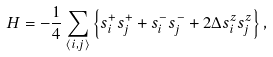Convert formula to latex. <formula><loc_0><loc_0><loc_500><loc_500>H = - \frac { 1 } { 4 } \sum _ { \langle i , j \rangle } \left \{ s _ { i } ^ { + } s _ { j } ^ { + } + s _ { i } ^ { - } s _ { j } ^ { - } + 2 \Delta s _ { i } ^ { z } s _ { j } ^ { z } \right \} ,</formula> 